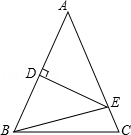Can you discuss the role of DE being perpendicular to AB and how that influences the properties of triangle EBC? DE being perpendicular to AB fundamentally creates right triangles within the larger triangle ABC, specifically forming right triangles ADE and CDE. This perpendicular line not only helps in defining the isosceles triangles but also aids in accurate partitioning of the sides, further simplifying calculations of lengths and angles using basic trigonometric identities. For triangle EBC, DE being perpendicular implies that it directly contributes to making right angles at E, which impacts how the lengths and angles of EBC are calculated and understood. 